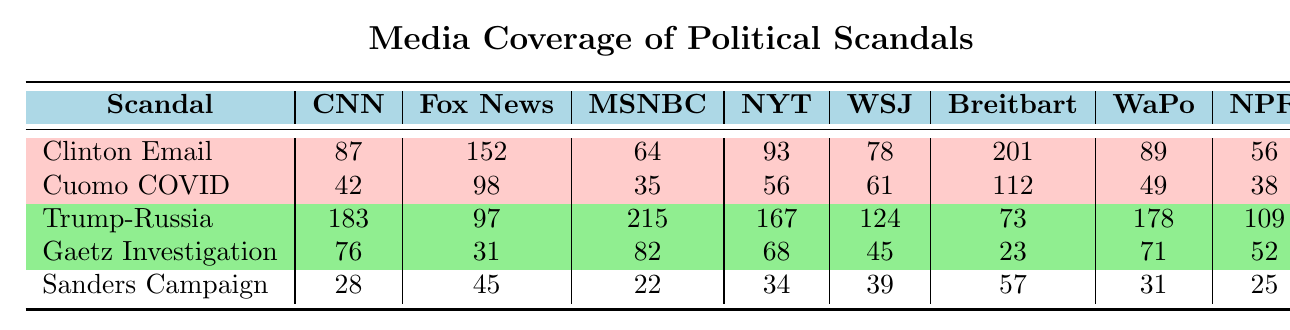What is the highest coverage for the "Clinton Email Controversy" by a news outlet? Looking at the "Clinton Email Controversy" row, we see the coverage values: CNN (87), Fox News (152), MSNBC (64), NYT (93), WSJ (78), Breitbart (201), WaPo (89), NPR (56). The highest value is 201 by Breitbart.
Answer: 201 Which news outlet provided the lowest coverage for the "Cuomo COVID Nursing Home Data"? In the "Cuomo COVID Nursing Home Data" row, the coverage values are: CNN (42), Fox News (98), MSNBC (35), NYT (56), WSJ (61), Breitbart (112), WaPo (49), NPR (38). The lowest value is 35 by MSNBC.
Answer: 35 What is the difference between the coverage of "Trump-Russia Collusion Investigation" by MSNBC and Fox News? The coverage for the "Trump-Russia Collusion Investigation" is 215 for MSNBC and 97 for Fox News. The difference is calculated as 215 - 97 = 118.
Answer: 118 Which scandal received the most total coverage across all news outlets? We need to sum the coverage values for each scandal. For "Clinton Email Controversy": 87 + 152 + 64 + 93 + 78 + 201 + 89 + 56 = 720. For "Cuomo COVID Nursing Home Data": 42 + 98 + 35 + 56 + 61 + 112 + 49 + 38 = 491. For "Trump-Russia Collusion Investigation": 183 + 97 + 215 + 167 + 124 + 73 + 178 + 109 = 1,126. For "Gaetz Sex Trafficking Investigation": 76 + 31 + 82 + 68 + 45 + 23 + 71 + 52 = 448. For "Sanders Campaign Finance Violation": 28 + 45 + 22 + 34 + 39 + 57 + 31 + 25 = 281. The highest total is for "Trump-Russia Collusion Investigation" with 1,126.
Answer: Trump-Russia Collusion Investigation Is it true that every news outlet covered the "Gaetz Sex Trafficking Investigation" more than the "Cuomo COVID Nursing Home Data"? We will check the coverage for each news outlet. For "Gaetz Sex Trafficking Investigation": CNN (76), Fox News (31), MSNBC (82), NYT (68), WSJ (45), Breitbart (23), WaPo (71), NPR (52). For "Cuomo COVID Nursing Home Data": CNN (42), Fox News (98), MSNBC (35), NYT (56), WSJ (61), Breitbart (112), WaPo (49), NPR (38). Comparing these, Fox News (31 < 98) and Breitbart (23 < 112) do not cover "Gaetz" more than "Cuomo". Hence, the statement is false.
Answer: No Which party affiliation had the highest total coverage across all scandals in the table? We will sum the coverage for each party across all scandals. Democratic: Clinton Email (720) + Cuomo (491) = 1,211. Republican: Trump-Russia (1,126) + Gaetz (448) = 1,574. Independent: Sanders (281). The highest total is for Republicans with 1,574.
Answer: Republican How many more times did Fox News cover the "Trump-Russia Collusion Investigation" compared to the "Sanders Campaign Finance Violation"? For "Trump-Russia Collusion Investigation," Fox News coverage is 97. For "Sanders Campaign Finance Violation," the coverage is 45. The difference is 97 - 45 = 52. Now, to find how many more times, we compute 97/45 ≈ 2.16. Thus, upon rounding down, Fox News covered the "Trump-Russia" scandal about 2 times more than the "Sanders" scandal.
Answer: 2 times 